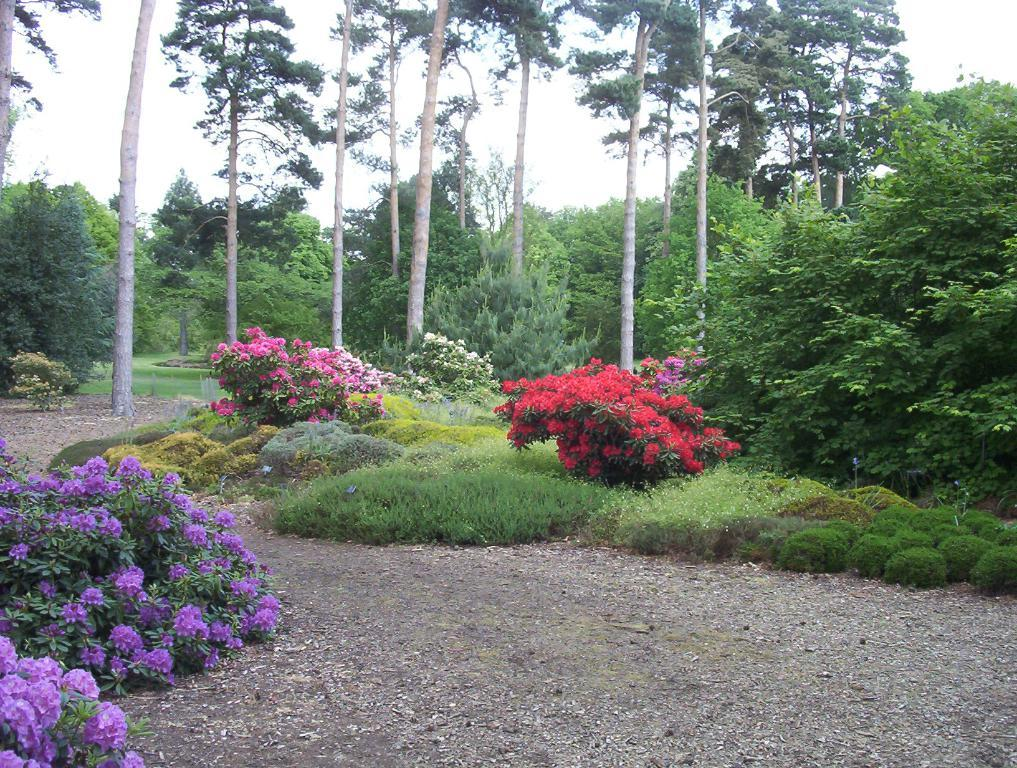What type of vegetation can be seen in the image? There is grass in the image, as well as plants and flowers at the bottom. What other natural elements are present in the image? There are trees in the background of the image. What is visible at the top of the image? The sky is visible at the top of the image. Can you tell me what fact the guitar is playing in the image? There is no guitar present in the image; it features grass, plants, flowers, trees, and the sky. What type of insect can be seen interacting with the plants and flowers in the image? There is no insect present in the image; it only features plants, flowers, trees, and the sky. 